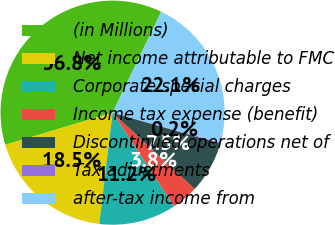Convert chart. <chart><loc_0><loc_0><loc_500><loc_500><pie_chart><fcel>(in Millions)<fcel>Net income attributable to FMC<fcel>Corporate special charges<fcel>Income tax expense (benefit)<fcel>Discontinued operations net of<fcel>Tax adjustments<fcel>after-tax income from<nl><fcel>36.78%<fcel>18.47%<fcel>11.15%<fcel>3.82%<fcel>7.48%<fcel>0.16%<fcel>22.13%<nl></chart> 